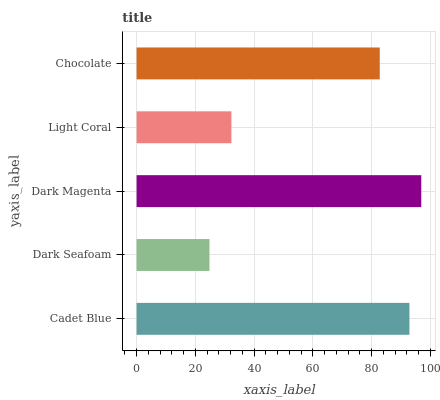Is Dark Seafoam the minimum?
Answer yes or no. Yes. Is Dark Magenta the maximum?
Answer yes or no. Yes. Is Dark Magenta the minimum?
Answer yes or no. No. Is Dark Seafoam the maximum?
Answer yes or no. No. Is Dark Magenta greater than Dark Seafoam?
Answer yes or no. Yes. Is Dark Seafoam less than Dark Magenta?
Answer yes or no. Yes. Is Dark Seafoam greater than Dark Magenta?
Answer yes or no. No. Is Dark Magenta less than Dark Seafoam?
Answer yes or no. No. Is Chocolate the high median?
Answer yes or no. Yes. Is Chocolate the low median?
Answer yes or no. Yes. Is Dark Magenta the high median?
Answer yes or no. No. Is Dark Magenta the low median?
Answer yes or no. No. 